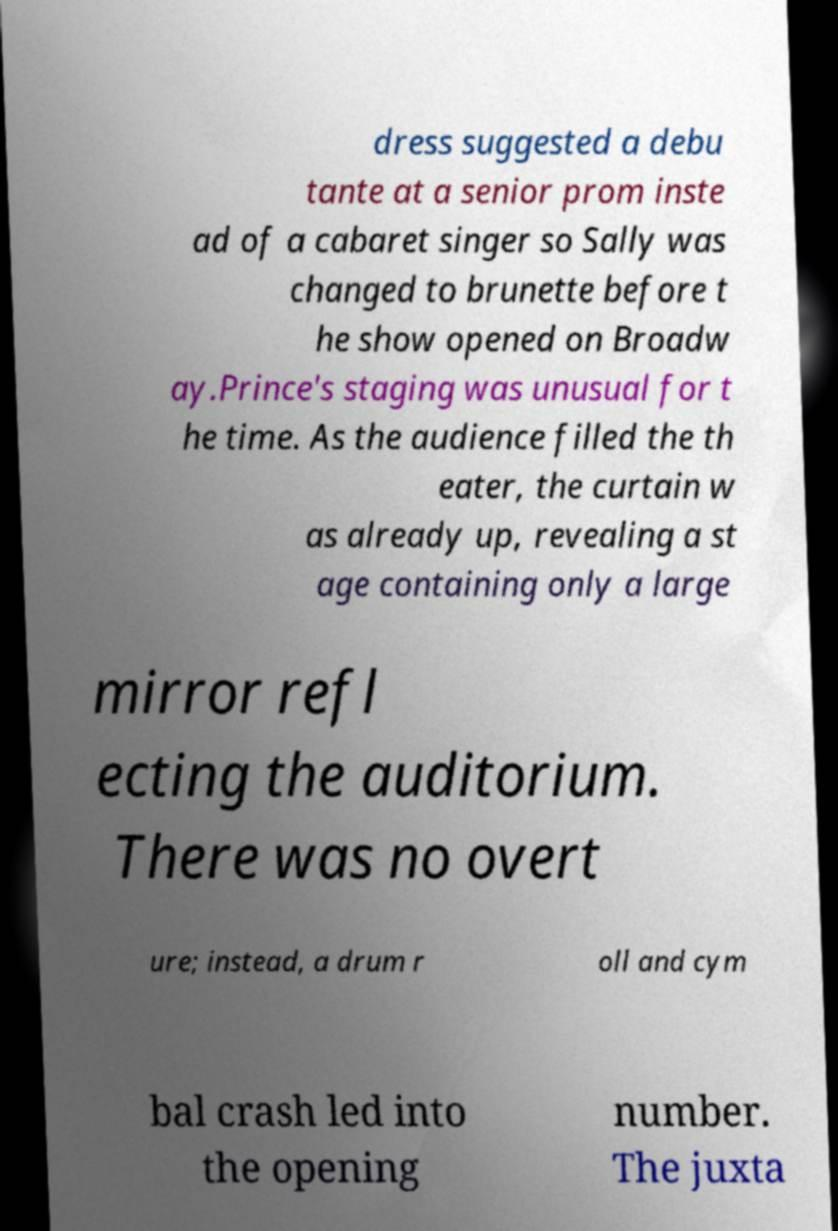I need the written content from this picture converted into text. Can you do that? dress suggested a debu tante at a senior prom inste ad of a cabaret singer so Sally was changed to brunette before t he show opened on Broadw ay.Prince's staging was unusual for t he time. As the audience filled the th eater, the curtain w as already up, revealing a st age containing only a large mirror refl ecting the auditorium. There was no overt ure; instead, a drum r oll and cym bal crash led into the opening number. The juxta 